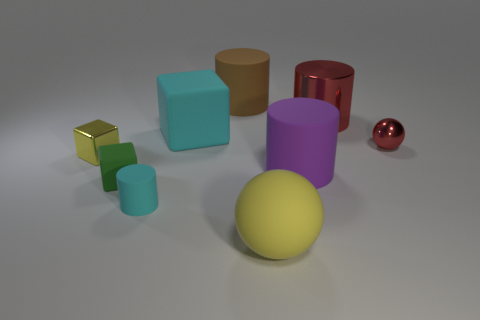Subtract all balls. How many objects are left? 7 Add 7 tiny matte blocks. How many tiny matte blocks exist? 8 Subtract 0 gray cylinders. How many objects are left? 9 Subtract all small cyan matte cylinders. Subtract all small metal blocks. How many objects are left? 7 Add 2 big cubes. How many big cubes are left? 3 